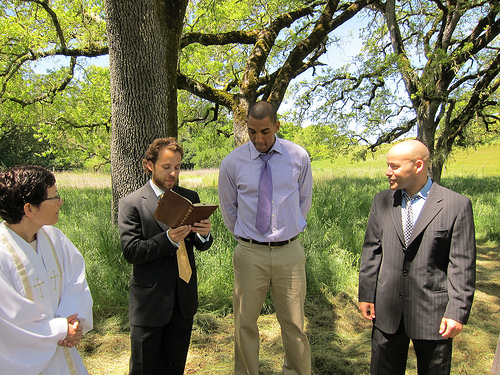<image>
Is the tree next to the man? Yes. The tree is positioned adjacent to the man, located nearby in the same general area. Is there a woman in front of the man? No. The woman is not in front of the man. The spatial positioning shows a different relationship between these objects. 